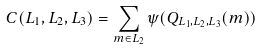<formula> <loc_0><loc_0><loc_500><loc_500>C ( L _ { 1 } , L _ { 2 } , L _ { 3 } ) = \sum _ { m \in L _ { 2 } } \psi ( Q _ { L _ { 1 } , L _ { 2 } , L _ { 3 } } ( m ) )</formula> 